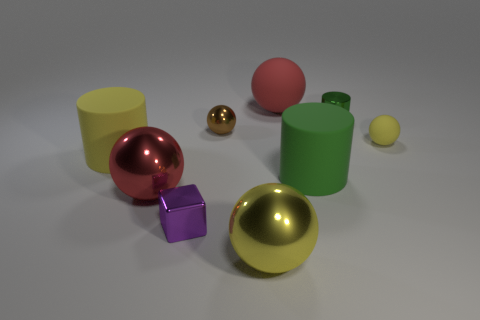Subtract all red metallic balls. How many balls are left? 4 Subtract all brown balls. How many balls are left? 4 Subtract all cyan balls. Subtract all red cubes. How many balls are left? 5 Add 1 yellow blocks. How many objects exist? 10 Subtract all blocks. How many objects are left? 8 Add 2 cyan matte spheres. How many cyan matte spheres exist? 2 Subtract 0 gray cubes. How many objects are left? 9 Subtract all tiny cylinders. Subtract all large green cylinders. How many objects are left? 7 Add 9 tiny green shiny cylinders. How many tiny green shiny cylinders are left? 10 